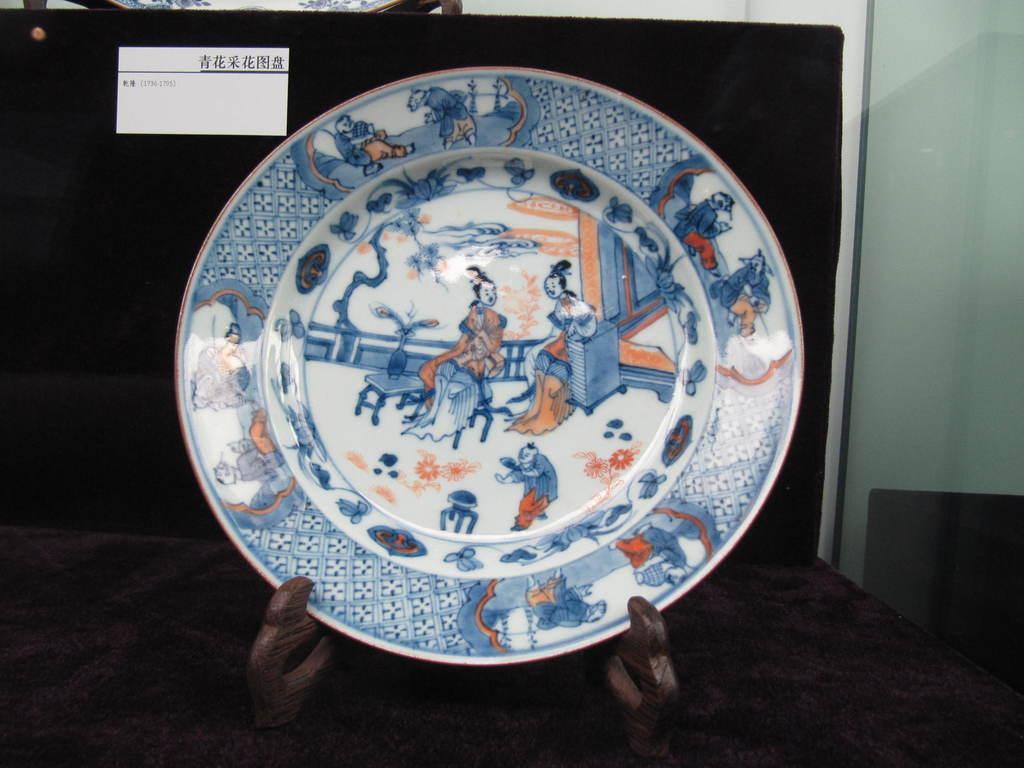Please provide a concise description of this image. There is a ceramic plate in the center of the image and there is a label on a blackboard in the background area, it seems like glass window on the right side. 